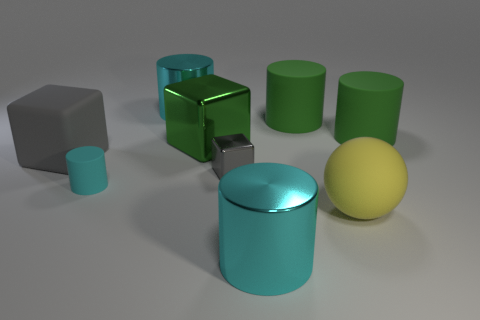How many cyan cylinders must be subtracted to get 1 cyan cylinders? 2 Subtract all big cylinders. How many cylinders are left? 1 Subtract all cyan cylinders. How many cylinders are left? 2 Subtract all purple cubes. How many green cylinders are left? 2 Add 6 big green blocks. How many big green blocks are left? 7 Add 9 big purple spheres. How many big purple spheres exist? 9 Subtract 0 purple balls. How many objects are left? 9 Subtract all balls. How many objects are left? 8 Subtract 4 cylinders. How many cylinders are left? 1 Subtract all purple cylinders. Subtract all blue blocks. How many cylinders are left? 5 